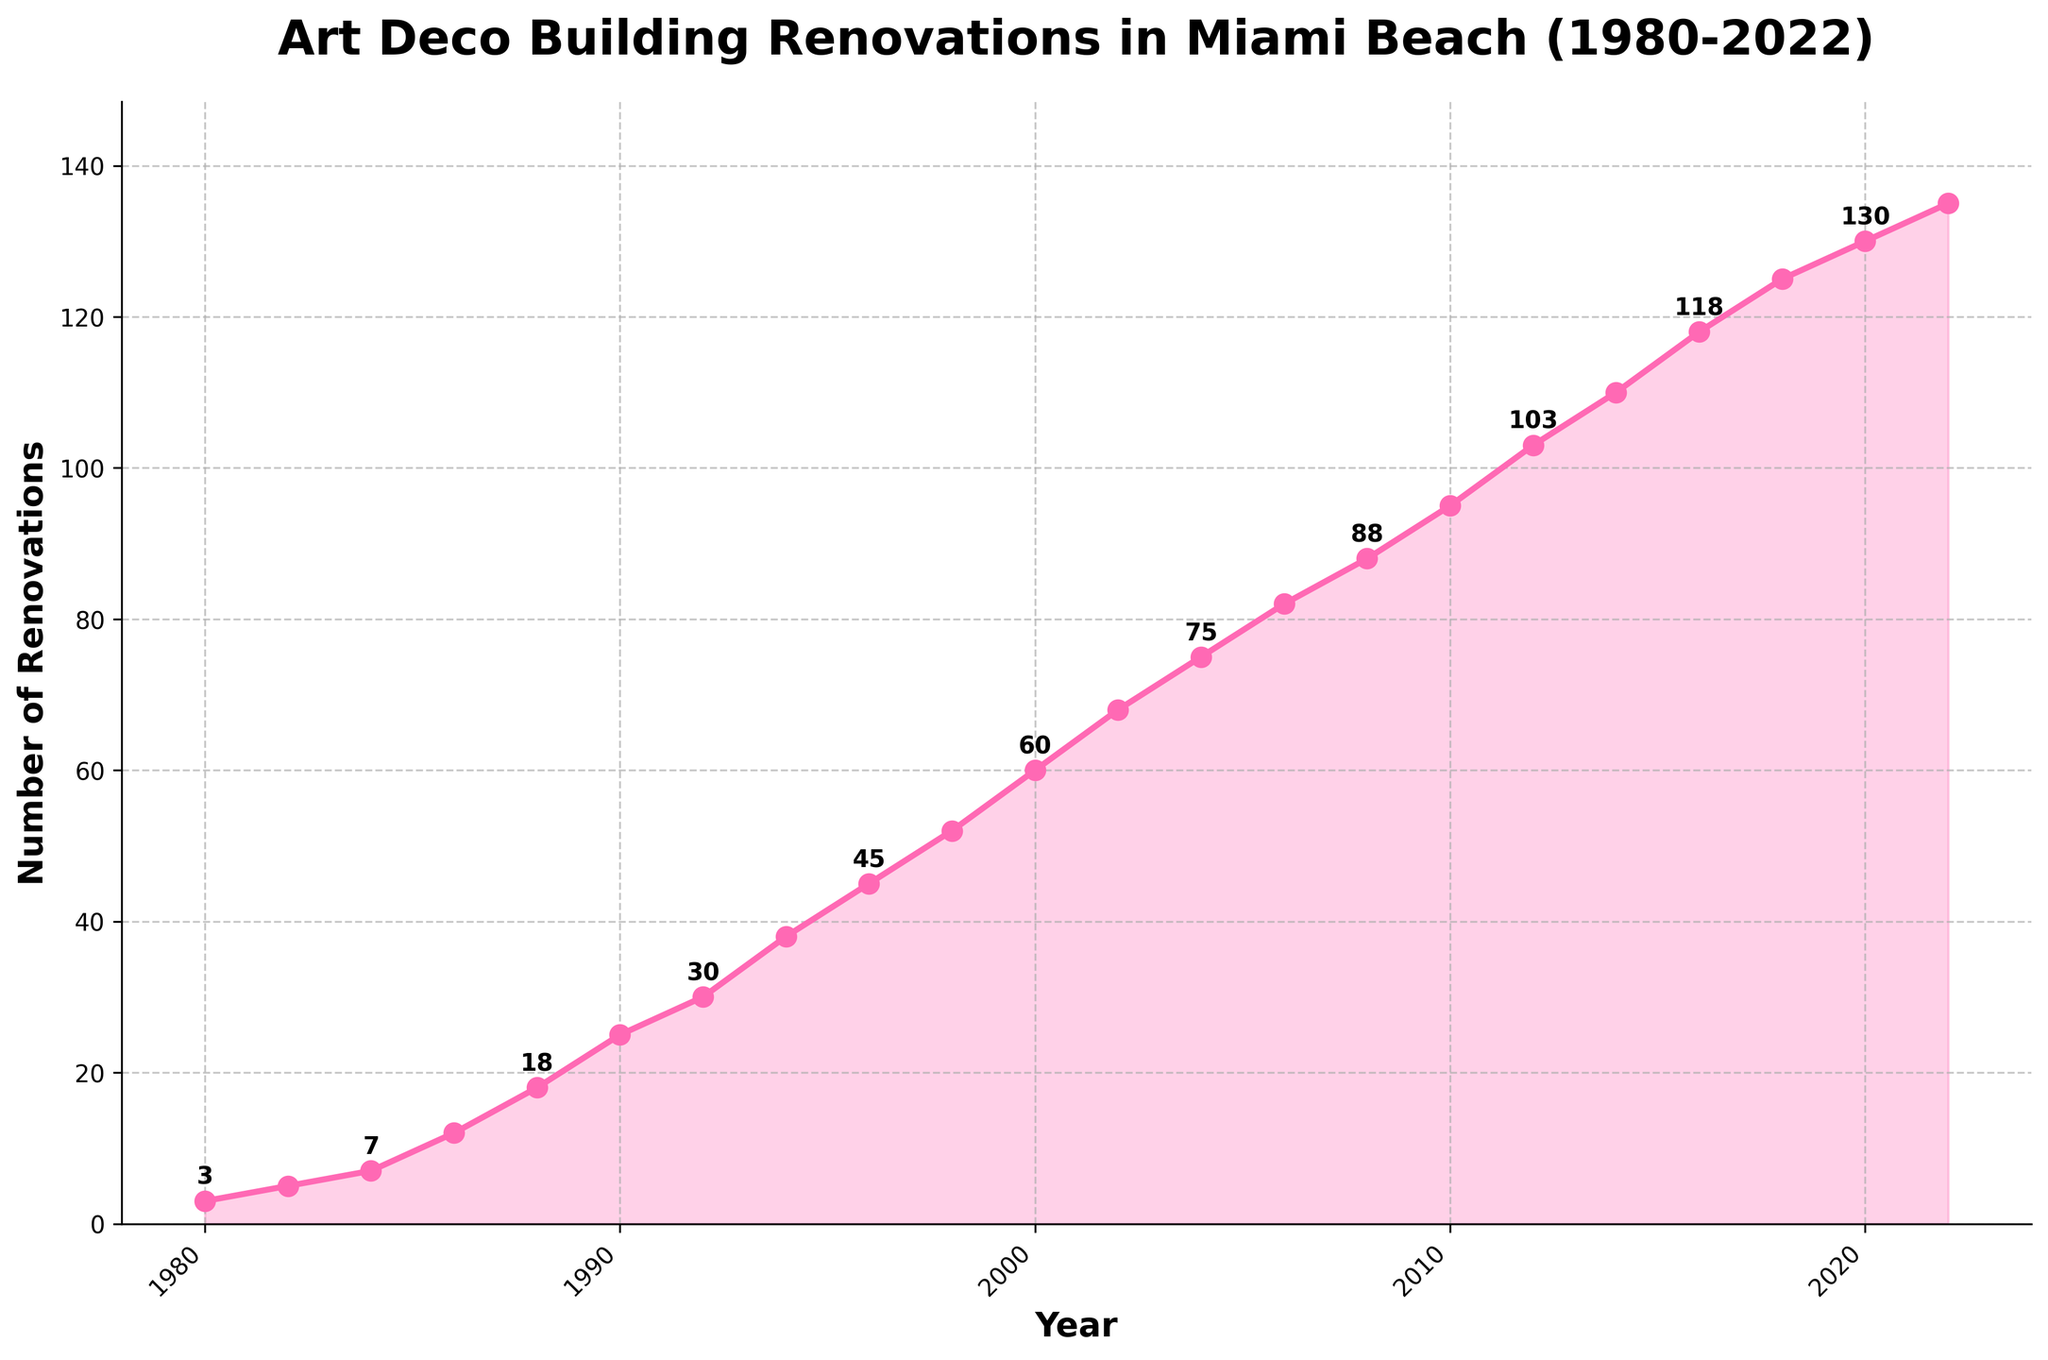What is the total number of Art Deco Building Renovations from 1980 to 2022? To find the total number of renovations from 1980 to 2022, sum the values corresponding to each year in the dataset. The calculation is: 3 + 5 + 7 + 12 + 18 + 25 + 30 + 38 + 45 + 52 + 60 + 68 + 75 + 82 + 88 + 95 + 103 + 110 + 118 + 125 + 130 + 135 = 1,331
Answer: 1,331 Which year saw the highest increase in the number of renovations compared to the previous year? To determine the highest increase, calculate the difference in the number of renovations between consecutive years and identify the largest one. From the figure, compare the slope between points: 1986 to 1988 (6), 1988 to 1990 (7), 1990 to 1992 (5), 1992 to 1994 (8), and so on. The highest increase is between 1988 and 1990.
Answer: 1988 to 1990 What is the average yearly increase in the number of renovations from 1980 to 2022? To calculate the average yearly increase, subtract the number of renovations in 1980 from that in 2022 and divide by the number of years (2022 - 1980). 135 (2022 value) - 3 (1980 value) = 132. The number of years is 2022 - 1980 = 42. Average increase = 132 / 42 = 3.14.
Answer: 3.14 Did the number of renovations ever decline between consecutive years from 1980 to 2022? By examining the plot, check if there is any point where the line descends between two consecutive years. The plot consistently ascends, indicating no decline in any year.
Answer: No How many renovations were there in 2010, and how does this compare to the year 2000? Refer to the figure to find the number of renovations in 2010 and 2000, then calculate the difference. In 2010, there were 95 renovations, and in 2000, there were 60. The difference is 95 - 60 = 35.
Answer: 35 more in 2010 What is the overall trend in the number of renovations across the years 1980-2022? Examine the slope of the line in the plot to describe the trend over the years. The plot shows an overall increasing trend from 1980 to 2022, as the number of renovations rises almost every year.
Answer: Increasing trend 